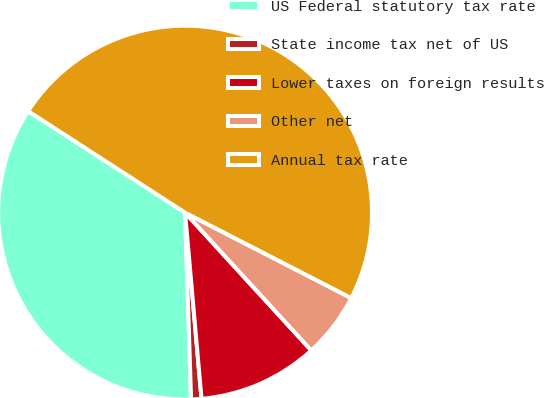Convert chart. <chart><loc_0><loc_0><loc_500><loc_500><pie_chart><fcel>US Federal statutory tax rate<fcel>State income tax net of US<fcel>Lower taxes on foreign results<fcel>Other net<fcel>Annual tax rate<nl><fcel>34.65%<fcel>0.89%<fcel>10.4%<fcel>5.64%<fcel>48.42%<nl></chart> 